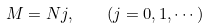Convert formula to latex. <formula><loc_0><loc_0><loc_500><loc_500>M = N j , \quad ( j = 0 , 1 , \cdots )</formula> 